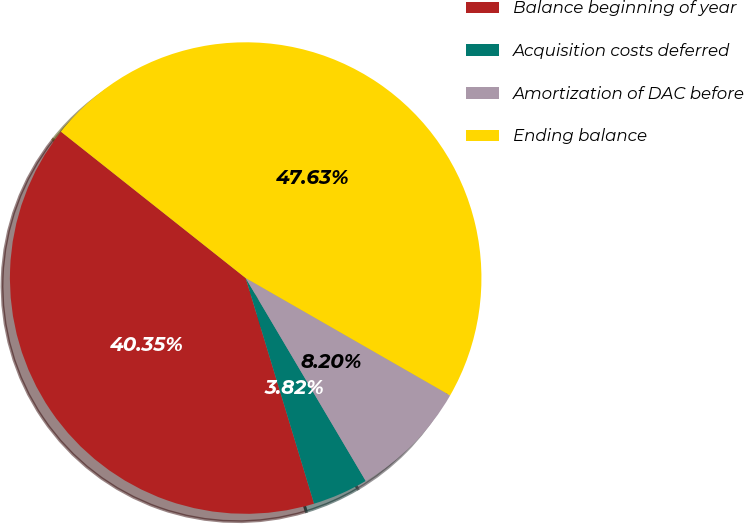Convert chart. <chart><loc_0><loc_0><loc_500><loc_500><pie_chart><fcel>Balance beginning of year<fcel>Acquisition costs deferred<fcel>Amortization of DAC before<fcel>Ending balance<nl><fcel>40.35%<fcel>3.82%<fcel>8.2%<fcel>47.63%<nl></chart> 